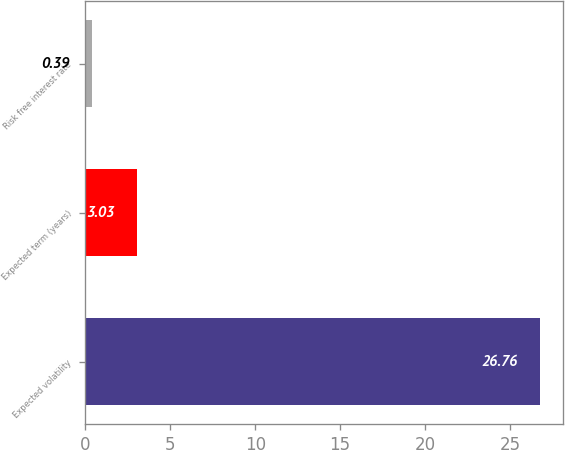Convert chart to OTSL. <chart><loc_0><loc_0><loc_500><loc_500><bar_chart><fcel>Expected volatility<fcel>Expected term (years)<fcel>Risk free interest rate<nl><fcel>26.76<fcel>3.03<fcel>0.39<nl></chart> 